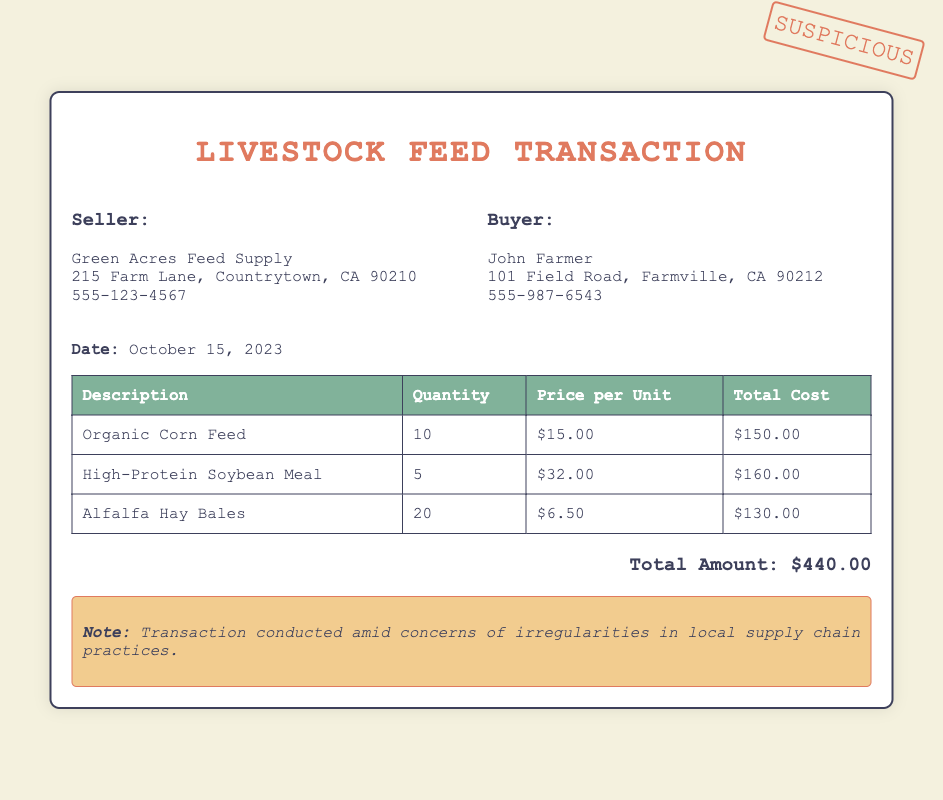What is the buyer's name? The buyer's name is located in the "Buyer" section of the document.
Answer: John Farmer What is the total cost for Organic Corn Feed? The total cost for Organic Corn Feed is listed in the table under "Total Cost" for that item.
Answer: $150.00 How many Alfalfa Hay Bales were purchased? The quantity of Alfalfa Hay Bales is stated in the table under "Quantity."
Answer: 20 What is the date of the transaction? The date is clearly noted in the document, providing the specific day of the purchase.
Answer: October 15, 2023 Who is the seller? The seller's name is found in the "Seller" section of the document.
Answer: Green Acres Feed Supply What is the price per unit of High-Protein Soybean Meal? The price per unit for High-Protein Soybean Meal can be found in the table next to that item.
Answer: $32.00 What is the warning noted in the document? The warning provides a caution about the conditions related to the transaction, mentioning supply chain practices.
Answer: Transaction conducted amid concerns of irregularities in local supply chain practices What is the total amount of the transaction? The total amount is aggregated at the bottom of the document, encompassing all items purchased.
Answer: $440.00 How many different feed types were purchased? The types of feed are indicated in the table, where each row represents a different type.
Answer: 3 